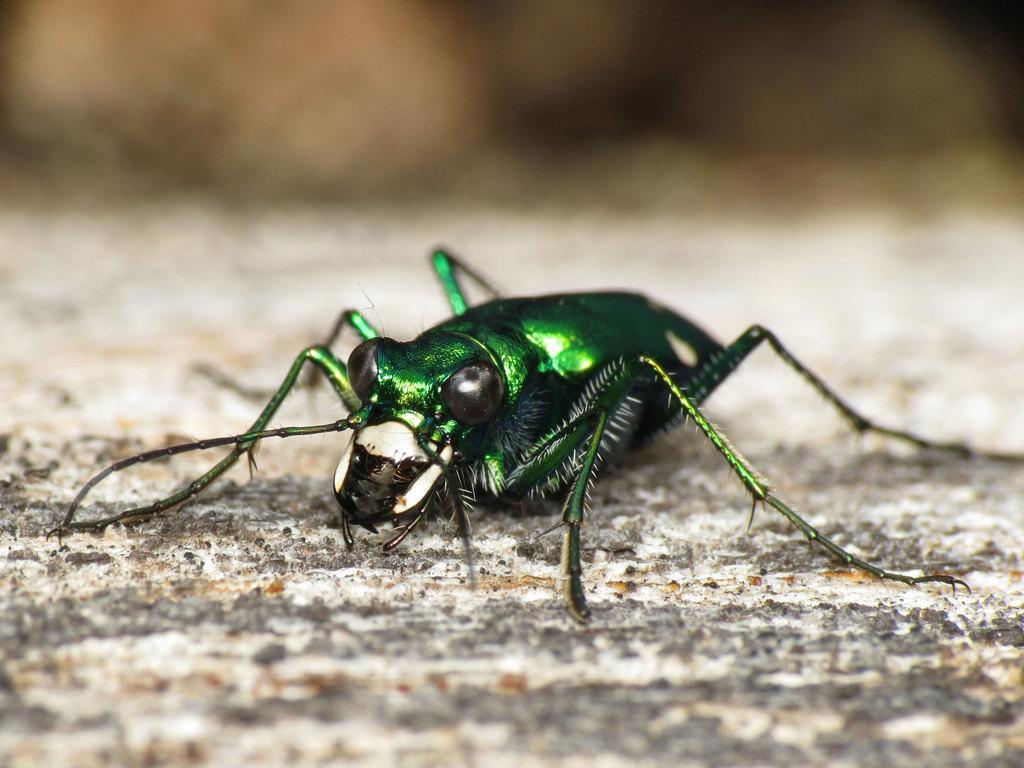Describe this image in one or two sentences. In this picture, we can see an insect on the ground, and we can see the blurred background. 